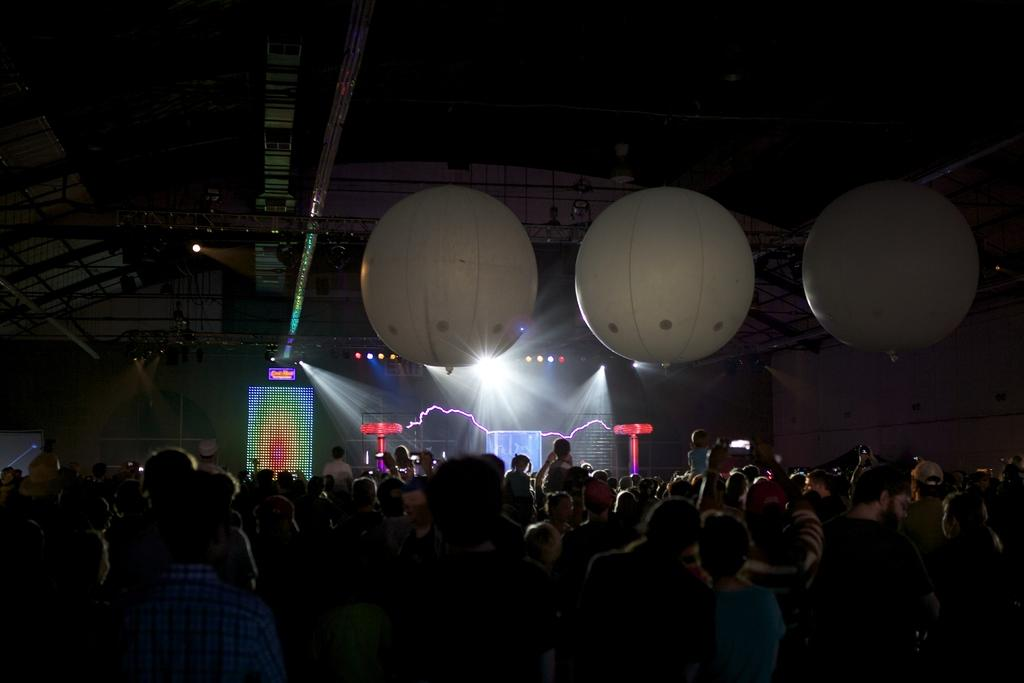Who or what is present on the roof in the image? There are people on the roof in the image. What else can be seen on the roof besides the people? Balloons, metal rods, and lights are visible on the roof. Can you describe the background of the image? There is a screen and other objects in the background of the image. What type of jeans are the dogs wearing in the image? There are no dogs present in the image, and therefore no jeans or any other clothing items can be observed. 